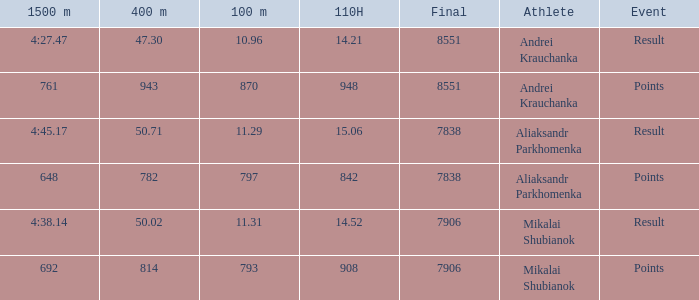Give me the full table as a dictionary. {'header': ['1500 m', '400 m', '100 m', '110H', 'Final', 'Athlete', 'Event'], 'rows': [['4:27.47', '47.30', '10.96', '14.21', '8551', 'Andrei Krauchanka', 'Result'], ['761', '943', '870', '948', '8551', 'Andrei Krauchanka', 'Points'], ['4:45.17', '50.71', '11.29', '15.06', '7838', 'Aliaksandr Parkhomenka', 'Result'], ['648', '782', '797', '842', '7838', 'Aliaksandr Parkhomenka', 'Points'], ['4:38.14', '50.02', '11.31', '14.52', '7906', 'Mikalai Shubianok', 'Result'], ['692', '814', '793', '908', '7906', 'Mikalai Shubianok', 'Points']]} What was the 110H that the 1500m was 692 and the final was more than 7906? 0.0. 